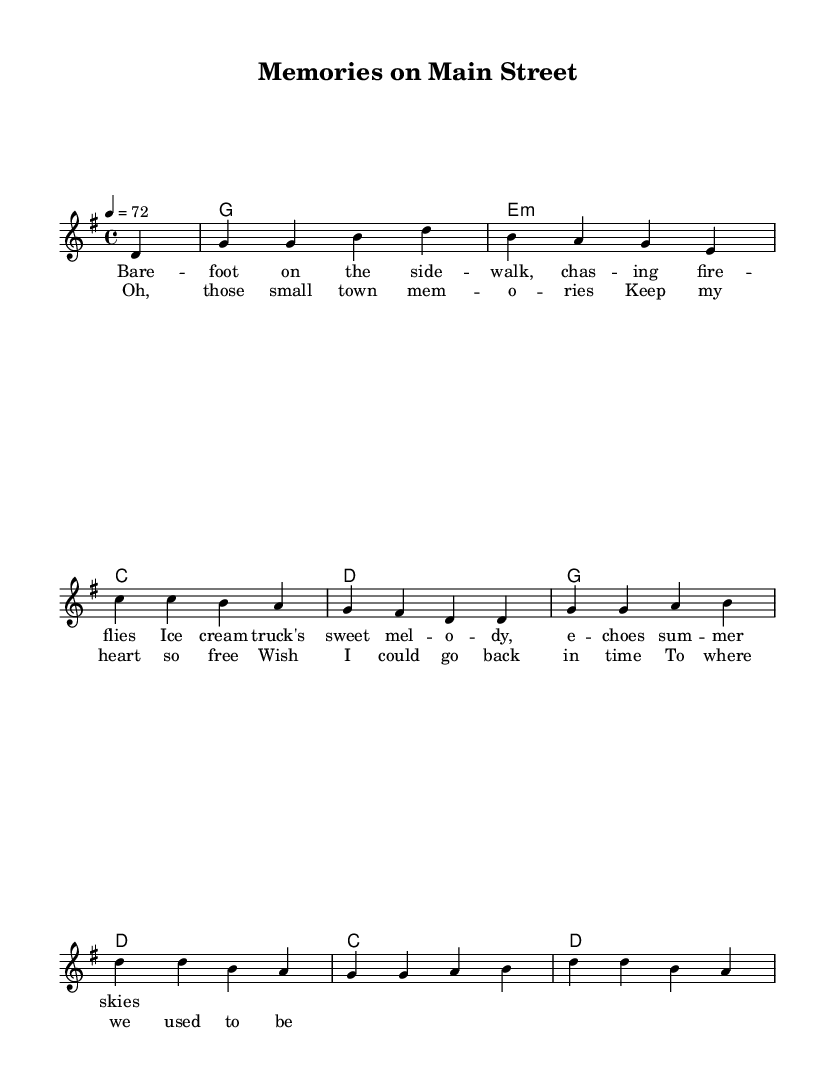What is the key signature of this music? The key signature indicates the key of G major, which has one sharp (F#). This is determined by the global variable at the beginning of the LilyPond code, where it states "\key g \major."
Answer: G major What is the time signature of this music? The time signature is indicated by the section that mentions "\time 4/4." This shows that there are four beats in each measure and the quarter note gets one beat.
Answer: 4/4 What is the tempo marking for this piece? The tempo is specified as "4 = 72," meaning there are 72 quarter note beats in a minute. This information is found in the global variable section of the code.
Answer: 72 What is the structure of the song based on its lyrics? The song consists of a verse followed by a chorus. This is evident because the lyrics are divided into sections labeled "verse" and "chorus." The verse has 2 lines, and the chorus has 4 lines.
Answer: Verse and Chorus What emotional theme is conveyed in the chorus of the song? The chorus reflects nostalgia and longing to return to a previous time, as indicated by the lyrics "Wish I could go back in time." This theme is common in Country Rock, which often focuses on personal and emotional storytelling.
Answer: Nostalgia How does the use of imagery in the verse contribute to the overall theme? The verse discusses memories of childhood activities, such as "barefoot on the sidewalk" and "chasing fireflies." This imagery evokes a sense of innocence and joy, reinforcing the nostalgic theme of the song.
Answer: Imagery of childhood 